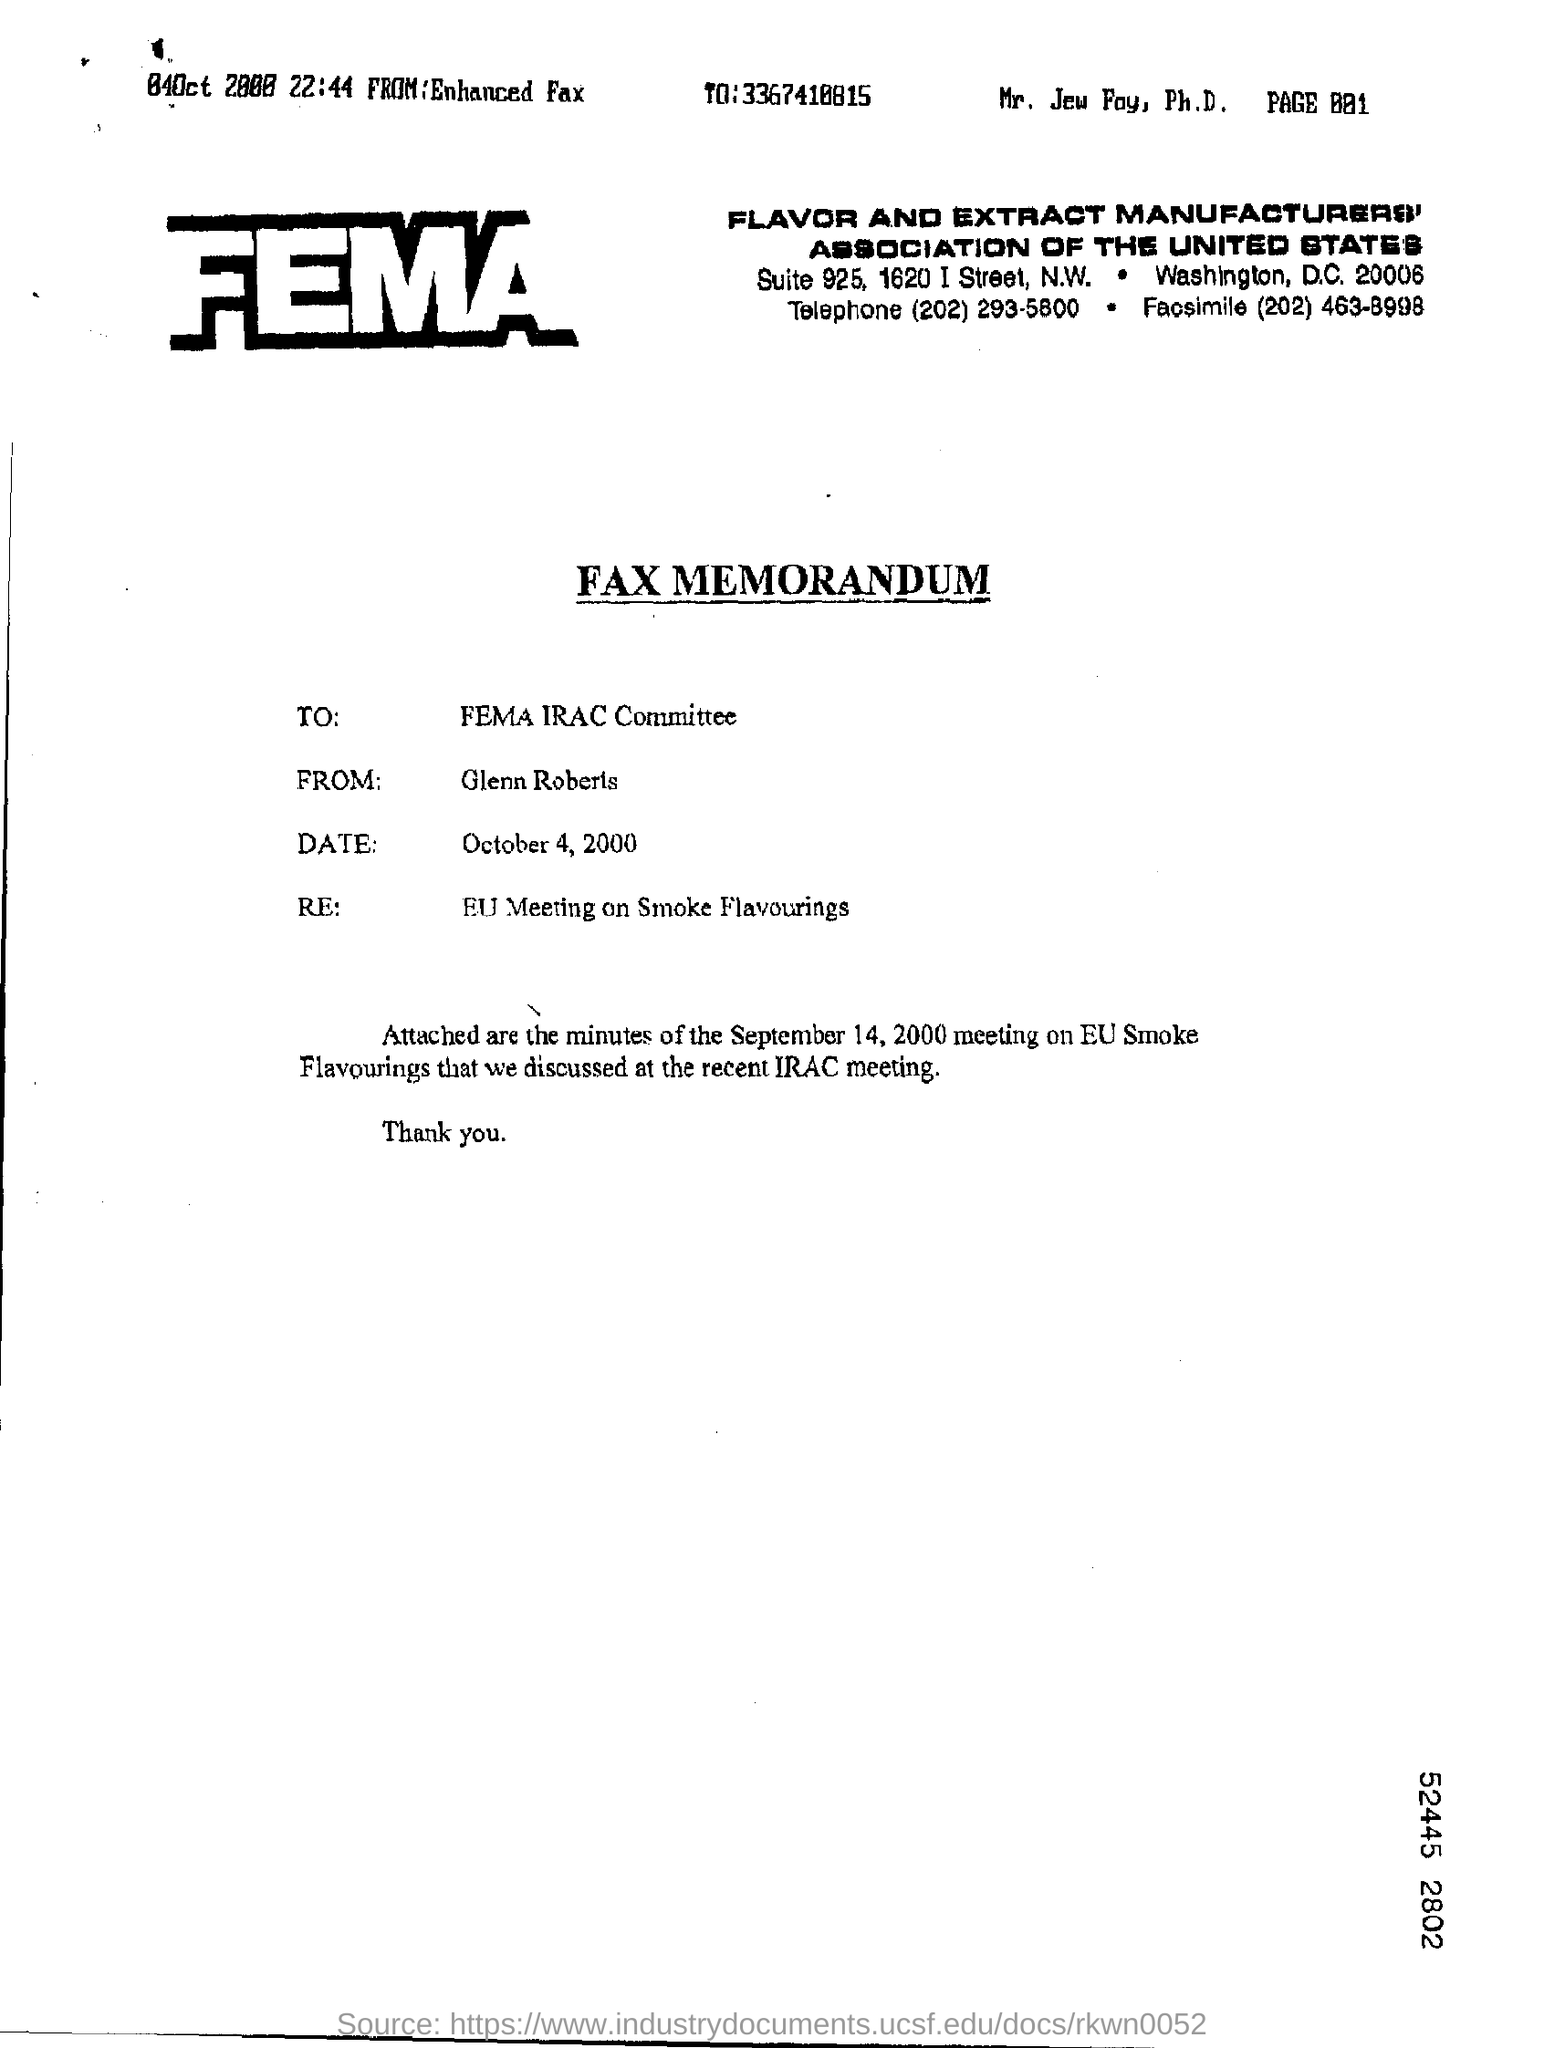What type of communication is this?
Give a very brief answer. FAX MEMORANDUM. To whom the memorandum is addressed?
Make the answer very short. FEMA IRAC Committee. What is the date of the memorandum?
Your response must be concise. October 4, 2000. What is the subject of Memorandum?
Ensure brevity in your answer.  EU Meeting on Smoke Flavourings. Which date's meeting minutes are attached in the memorandum?
Make the answer very short. September 14, 2000. What is the name of the sender in the Fax Memorandum?
Your answer should be compact. Glenn Roberts. What is the telephone number mentioned in the 'FEMA' letter head?
Make the answer very short. (202) 293-5800. What is the 'Facsimile' number mentioned in the letter head?
Keep it short and to the point. (202) 463-8998. 